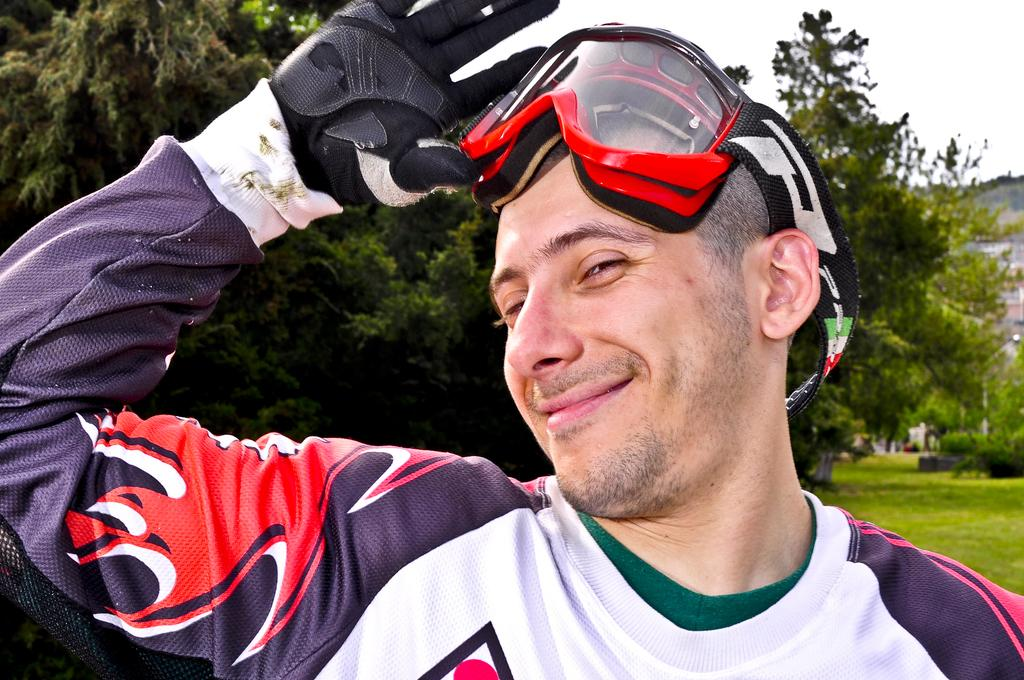What is the man in the image wearing on his upper body? The man is wearing a T-shirt in the image. What type of accessory is the man wearing on his hand? The man is wearing a black glove in the image. What type of eyewear is the man wearing in the image? The man is wearing glasses in the image. What type of natural environment can be seen in the background of the image? There is grass, trees, and a hill visible in the background of the image. What type of beam is the man using to cover the trees in the image? There is no beam present in the image, and the trees are not being covered. 